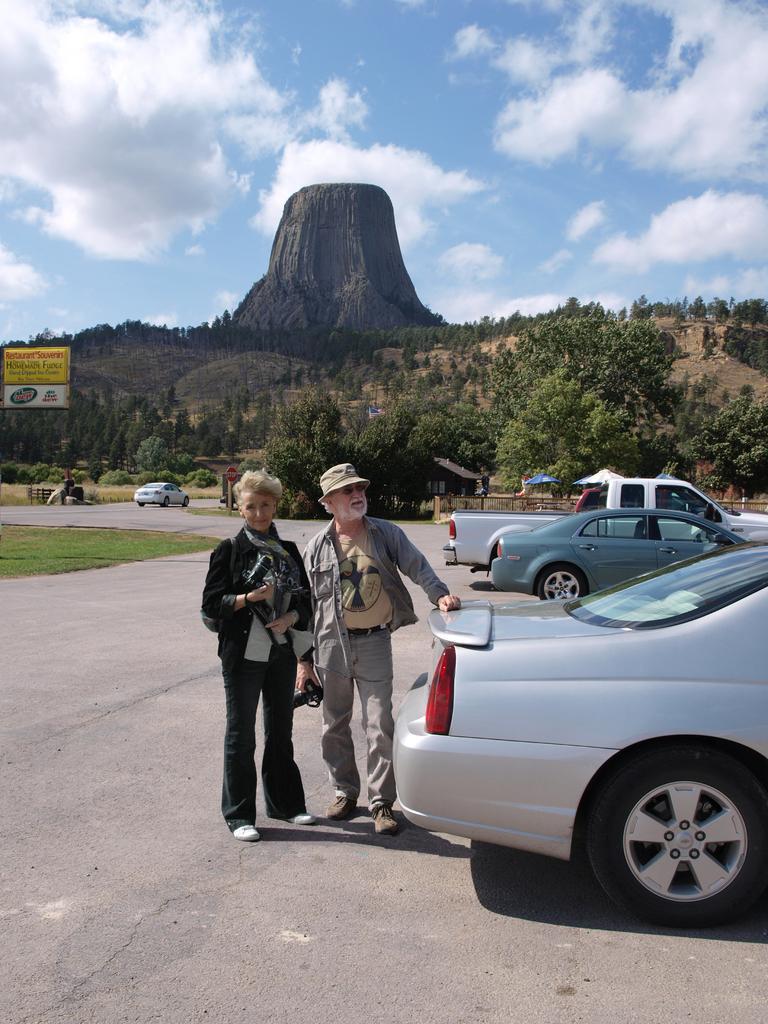How would you summarize this image in a sentence or two? In this picture there is a man and a woman in the center of the image and there are cars on the right side of the image and there is another car, poster in the image and there is greenery a cliff in the background area of the image. 